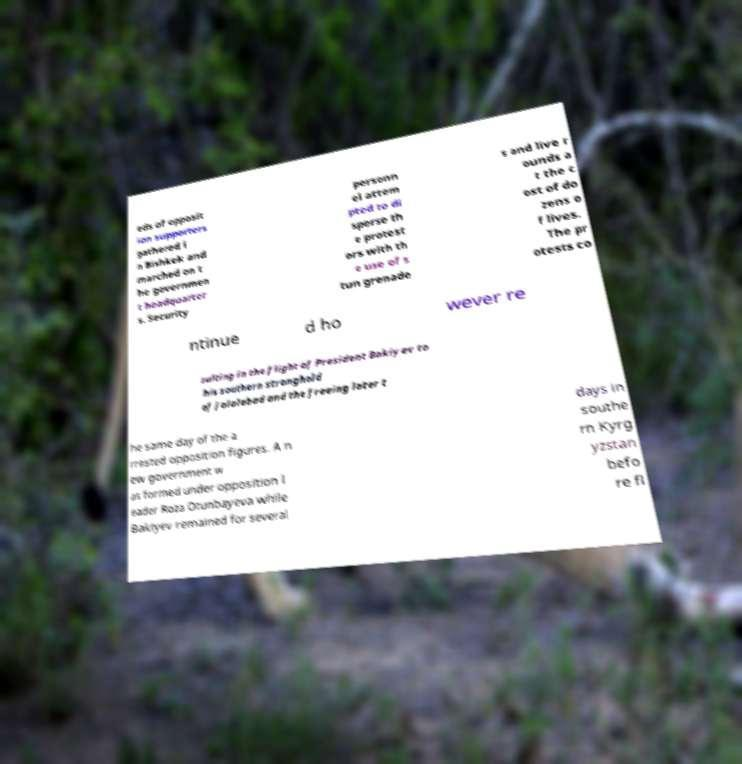I need the written content from this picture converted into text. Can you do that? eds of opposit ion supporters gathered i n Bishkek and marched on t he governmen t headquarter s. Security personn el attem pted to di sperse th e protest ors with th e use of s tun grenade s and live r ounds a t the c ost of do zens o f lives. The pr otests co ntinue d ho wever re sulting in the flight of President Bakiyev to his southern stronghold of Jalalabad and the freeing later t he same day of the a rrested opposition figures. A n ew government w as formed under opposition l eader Roza Otunbayeva while Bakiyev remained for several days in southe rn Kyrg yzstan befo re fl 